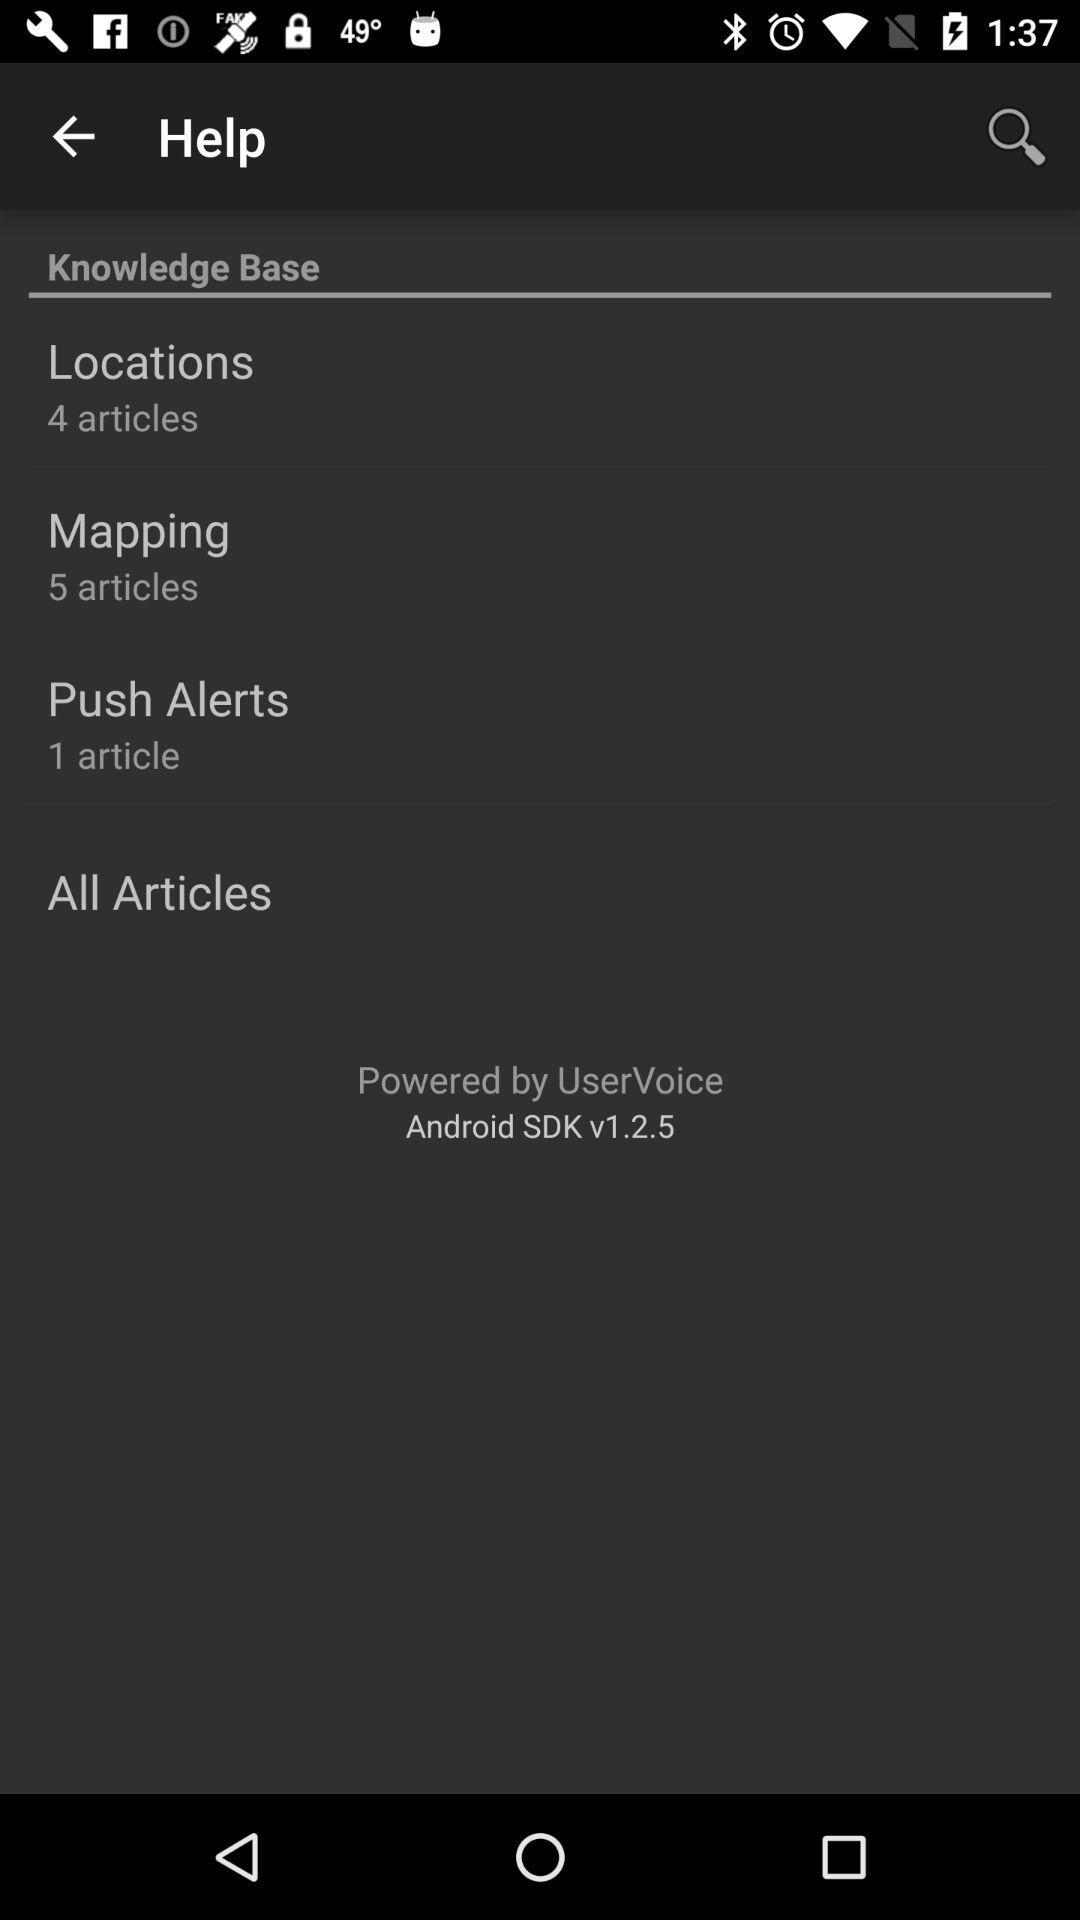How many articles are in push alerts? There is 1 article in push alerts. 